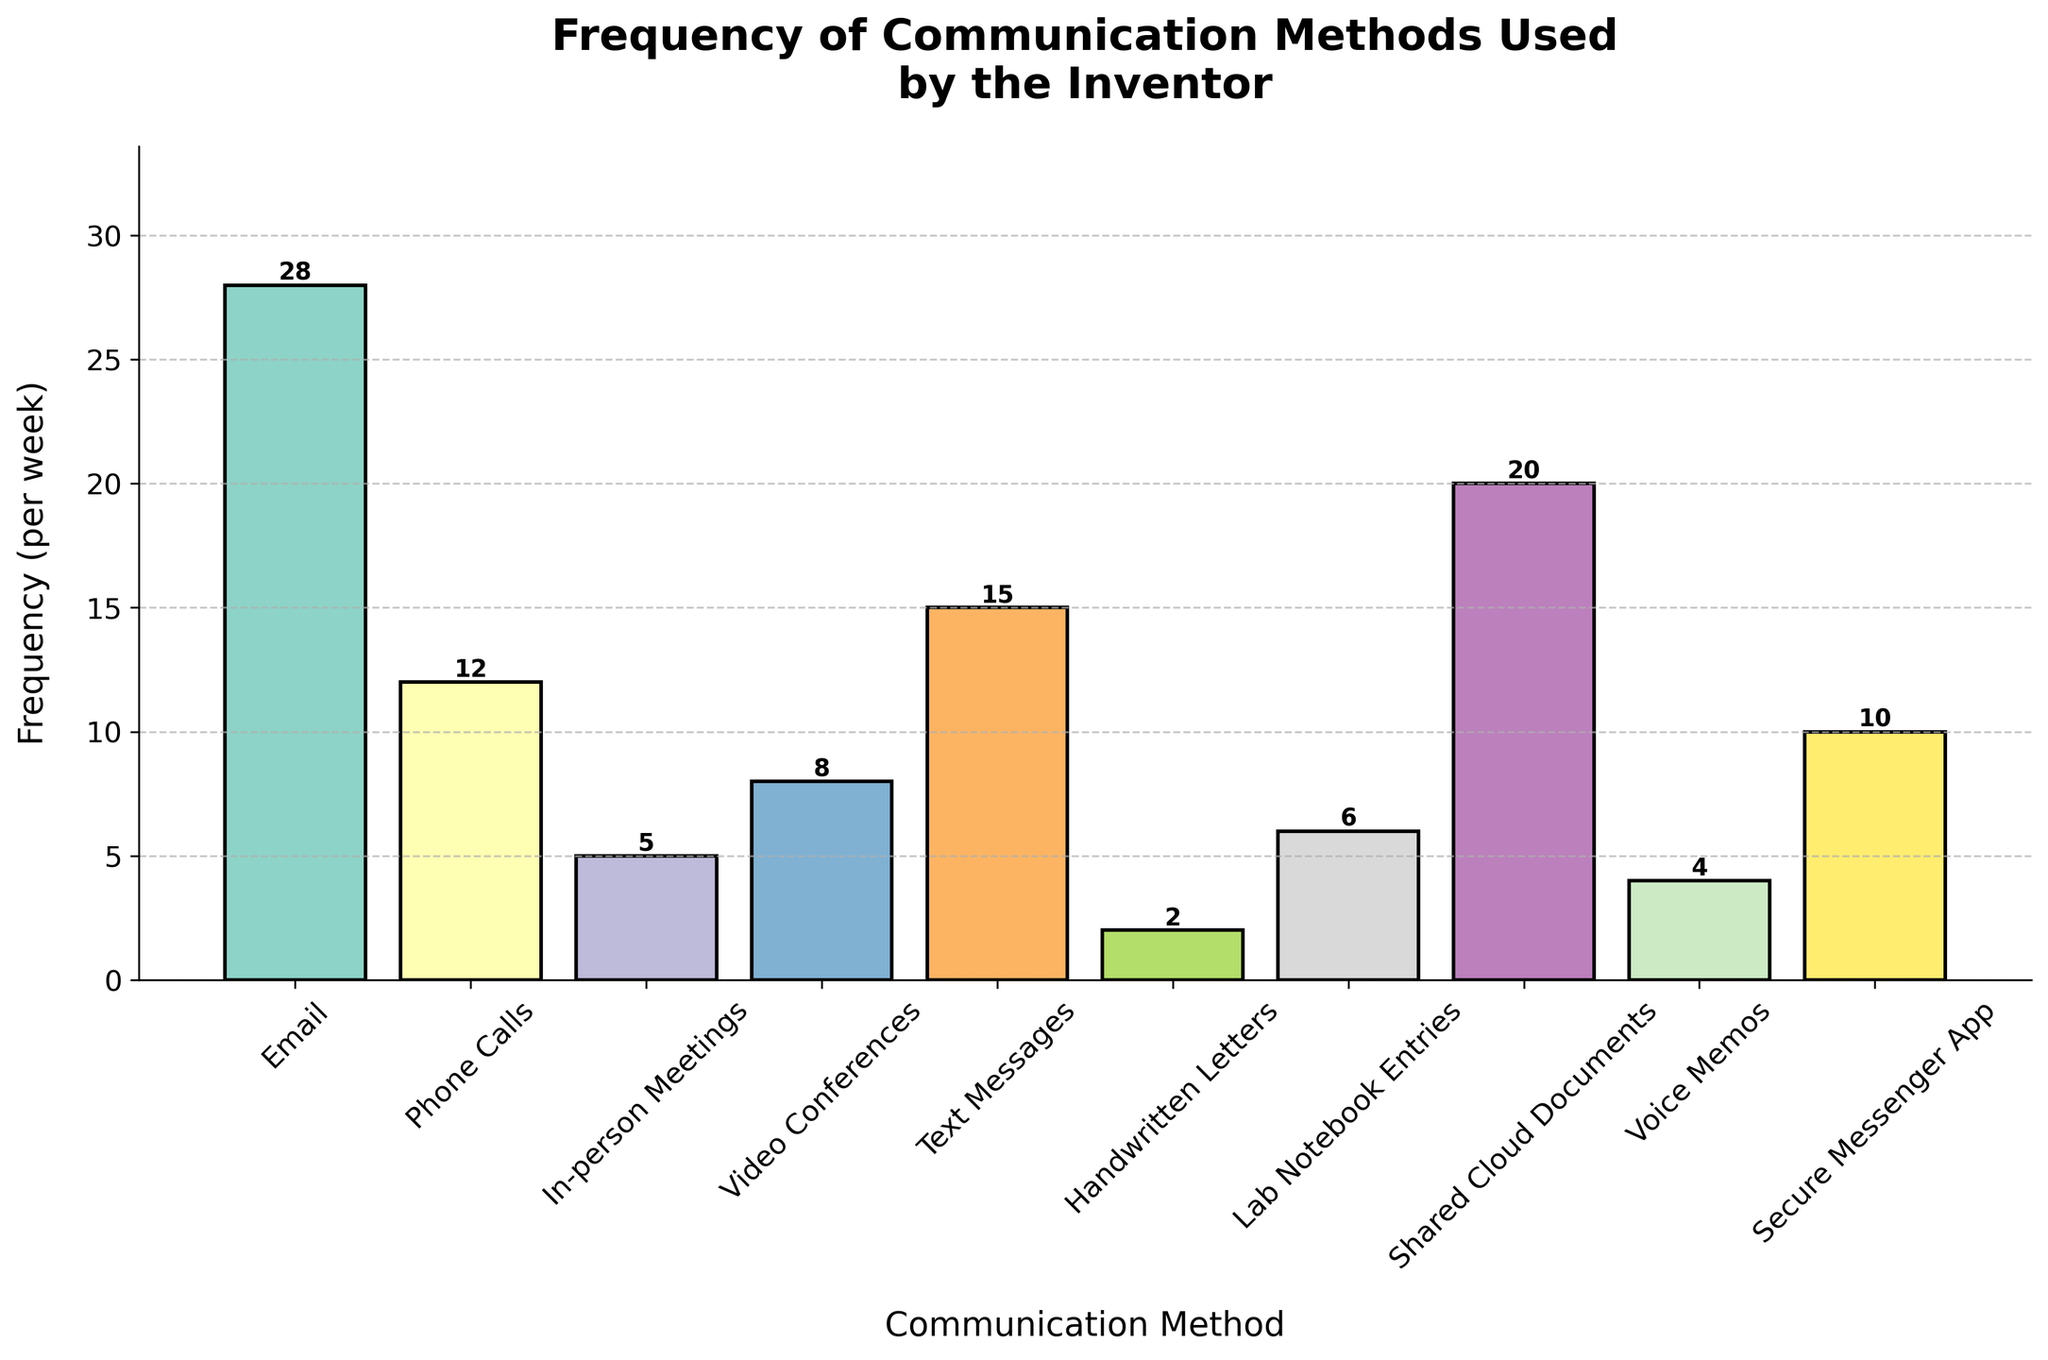Which communication method is used most frequently? By observing the height of the bars, the tallest bar represents the most frequently used method. In this case, the bar for "Email" is the tallest.
Answer: Email Which communication method has the lowest frequency? The shortest bar represents the least frequently used method. The bar for "Handwritten Letters" is the shortest.
Answer: Handwritten Letters What is the sum of the frequencies of "In-person Meetings" and "Video Conferences"? Add the frequencies of "In-person Meetings" (5) and "Video Conferences" (8). 5 + 8 = 13.
Answer: 13 Is the frequency of "Text Messages" greater than or less than "Phone Calls"? Compare the heights of the bars for "Text Messages" (15) and "Phone Calls" (12). "Text Messages" has a higher bar, indicating a greater frequency.
Answer: Greater What is the combined frequency of "Emails," "Shared Cloud Documents," and "Secure Messenger App"? Sum the frequencies: Emails (28) + Shared Cloud Documents (20) + Secure Messenger App (10). 28 + 20 + 10 = 58.
Answer: 58 Which communication methods have a frequency greater than 10 but less than 20? Identify the bars whose frequency values fall in the interval (10, 20). "Text Messages" (15), "Shared Cloud Documents" (20), and "Secure Messenger App" (10).
Answer: Text Messages, Shared Cloud Documents, Secure Messenger App What is the average frequency of "Emails," "Phone Calls," and "In-person Meetings"? Calculate the sum of frequencies of Emails (28), Phone Calls (12), and In-person Meetings (5), then divide by the number of methods. (28 + 12 + 5) / 3 = 45 / 3 = 15.
Answer: 15 By how much does the frequency of "Emails" exceed that of "Text Messages"? Subtract the frequency of "Text Messages" (15) from that of "Emails" (28). 28 - 15 = 13.
Answer: 13 Does the sum of frequencies for "Lab Notebook Entries" and "Voice Memos" equal the frequency of "Text Messages"? Add the frequencies of "Lab Notebook Entries" (6) and "Voice Memos" (4). 6 + 4 = 10. Compare this sum to the frequency of "Text Messages" (15). 10 is less than 15.
Answer: No What is the difference between the highest and lowest frequencies recorded? Subtract the lowest frequency (Handwritten Letters: 2) from the highest frequency (Emails: 28). 28 - 2 = 26.
Answer: 26 